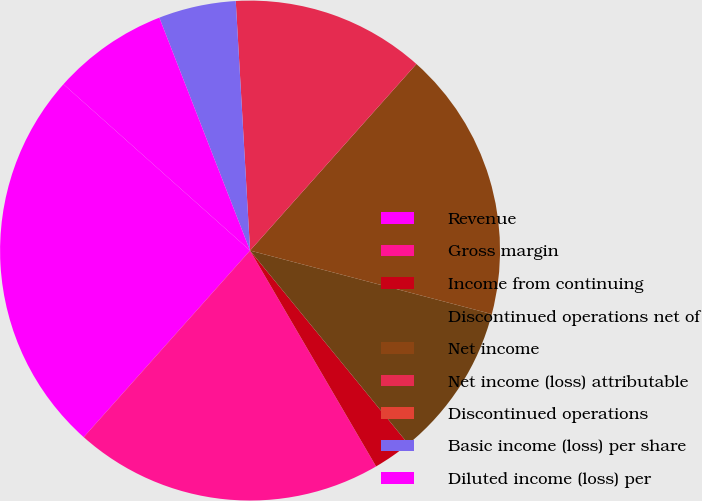<chart> <loc_0><loc_0><loc_500><loc_500><pie_chart><fcel>Revenue<fcel>Gross margin<fcel>Income from continuing<fcel>Discontinued operations net of<fcel>Net income<fcel>Net income (loss) attributable<fcel>Discontinued operations<fcel>Basic income (loss) per share<fcel>Diluted income (loss) per<nl><fcel>25.0%<fcel>20.0%<fcel>2.5%<fcel>10.0%<fcel>17.5%<fcel>12.5%<fcel>0.0%<fcel>5.0%<fcel>7.5%<nl></chart> 